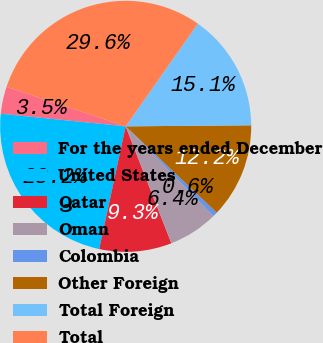Convert chart. <chart><loc_0><loc_0><loc_500><loc_500><pie_chart><fcel>For the years ended December<fcel>United States<fcel>Qatar<fcel>Oman<fcel>Colombia<fcel>Other Foreign<fcel>Total Foreign<fcel>Total<nl><fcel>3.5%<fcel>23.22%<fcel>9.31%<fcel>6.4%<fcel>0.59%<fcel>12.21%<fcel>15.12%<fcel>29.64%<nl></chart> 